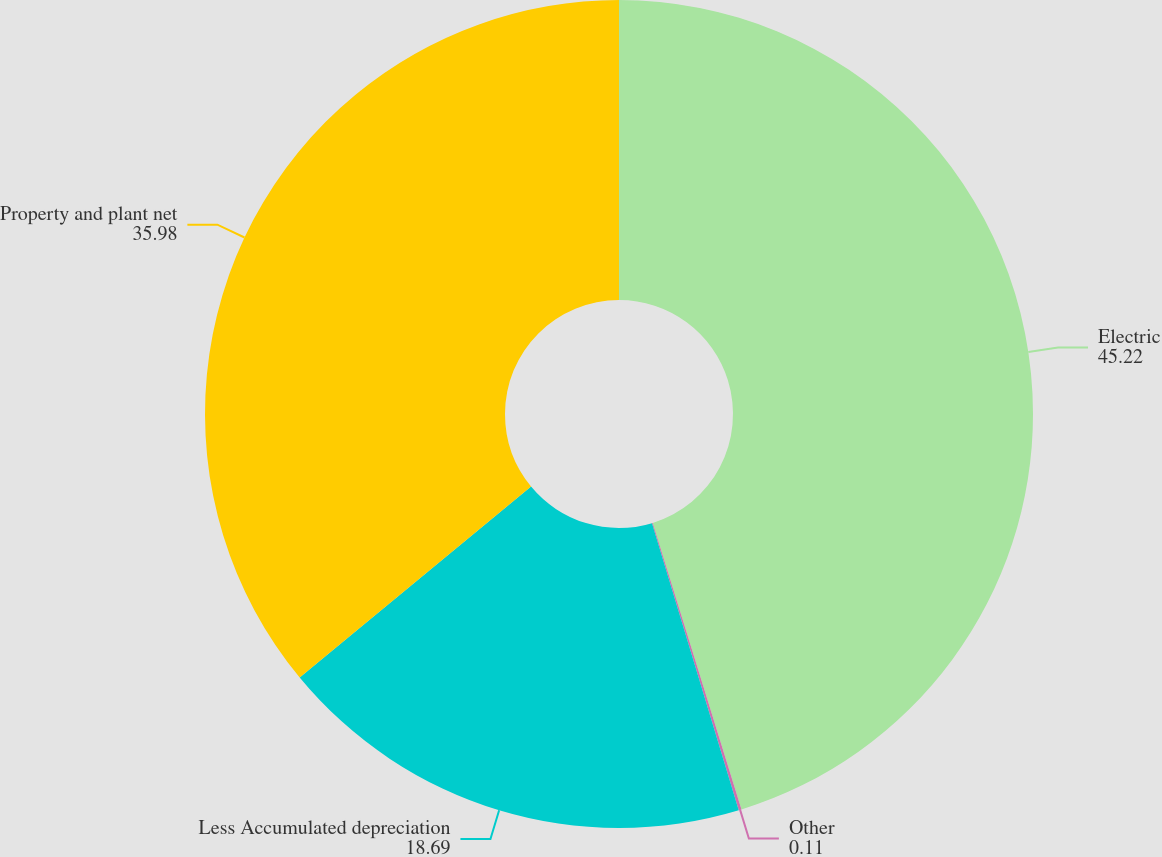Convert chart. <chart><loc_0><loc_0><loc_500><loc_500><pie_chart><fcel>Electric<fcel>Other<fcel>Less Accumulated depreciation<fcel>Property and plant net<nl><fcel>45.22%<fcel>0.11%<fcel>18.69%<fcel>35.98%<nl></chart> 